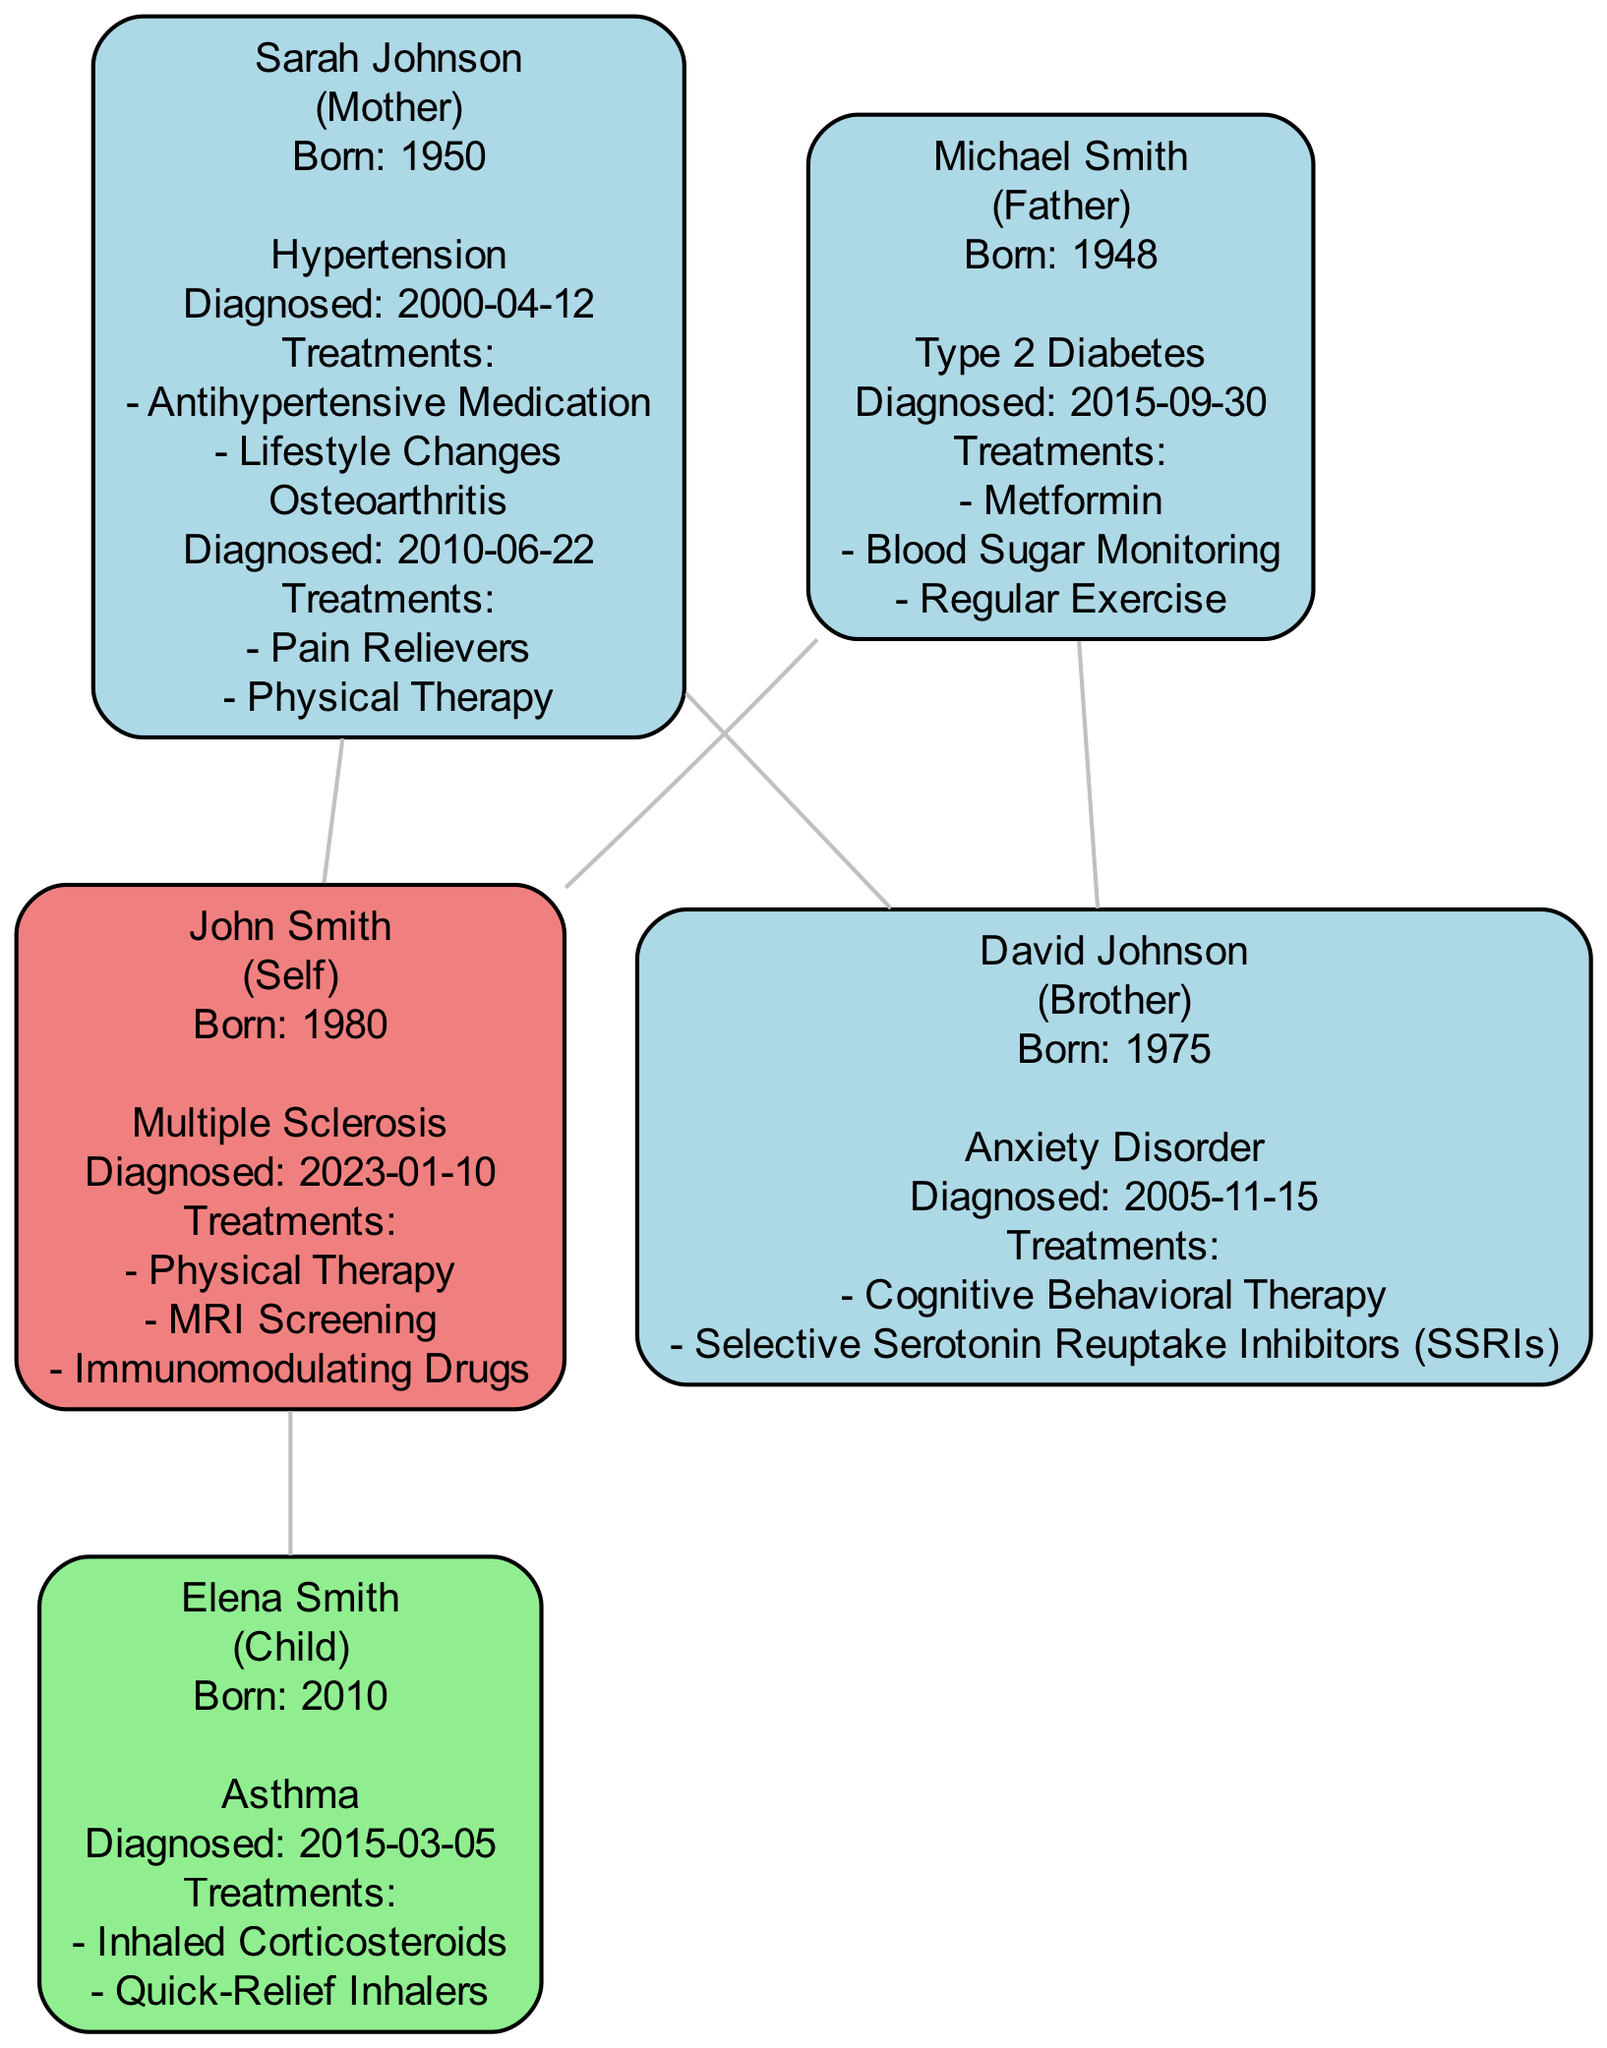What condition was diagnosed for John Smith? The diagram shows that John Smith has a diagnosis of Multiple Sclerosis, which is mentioned under his node.
Answer: Multiple Sclerosis What is the birth year of Elena Smith? By looking at Elena Smith's node in the diagram, it states that she was born in 2010.
Answer: 2010 How many family members are listed in the diagram? By counting all the nodes related to individuals, there are five family members: John Smith, Elena Smith, Sarah Johnson, Michael Smith, and David Johnson.
Answer: 5 Which treatment is listed for Sarah Johnson's hypertension? The diagram specifies that Sarah Johnson's treatments for hypertension include Antihypertensive Medication and Lifestyle Changes. The mention of Antihypertensive Medication indicates her primary treatment.
Answer: Antihypertensive Medication What is the relationship between David Johnson and John Smith? The diagram illustrates that David Johnson is a brother of John Smith, as indicated by the connections drawn between their nodes.
Answer: Brother What condition does Elena Smith have? From the diagram, it is noted beneath Elena Smith's node that she has Asthma, which is her diagnosed condition.
Answer: Asthma Which parent has a diagnosis of Type 2 Diabetes? The diagram clearly shows that Michael Smith, who is represented as the father, has a diagnosis of Type 2 Diabetes.
Answer: Michael Smith How are John Smith and Sarah Johnson related? The diagram depicts that Sarah Johnson is the mother of John Smith, as indicated by the direction of the connection lines leading to John.
Answer: Mother What treatments are listed for David Johnson's anxiety disorder? The diagram details that David Johnson received Cognitive Behavioral Therapy and Selective Serotonin Reuptake Inhibitors (SSRIs) as treatments for his anxiety disorder.
Answer: Cognitive Behavioral Therapy and Selective Serotonin Reuptake Inhibitors (SSRIs) 